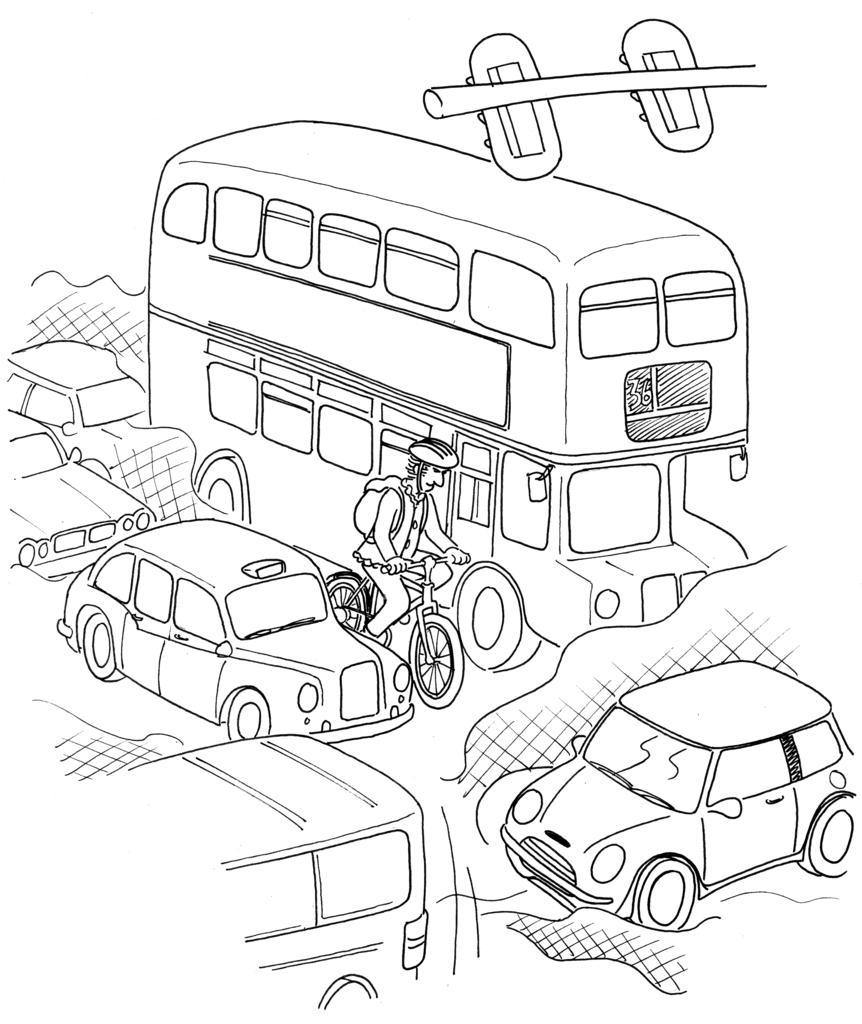Please provide a concise description of this image. In this image, we can see a sketch of some vehicles and person wearing a bag and sitting on the bicycle. 